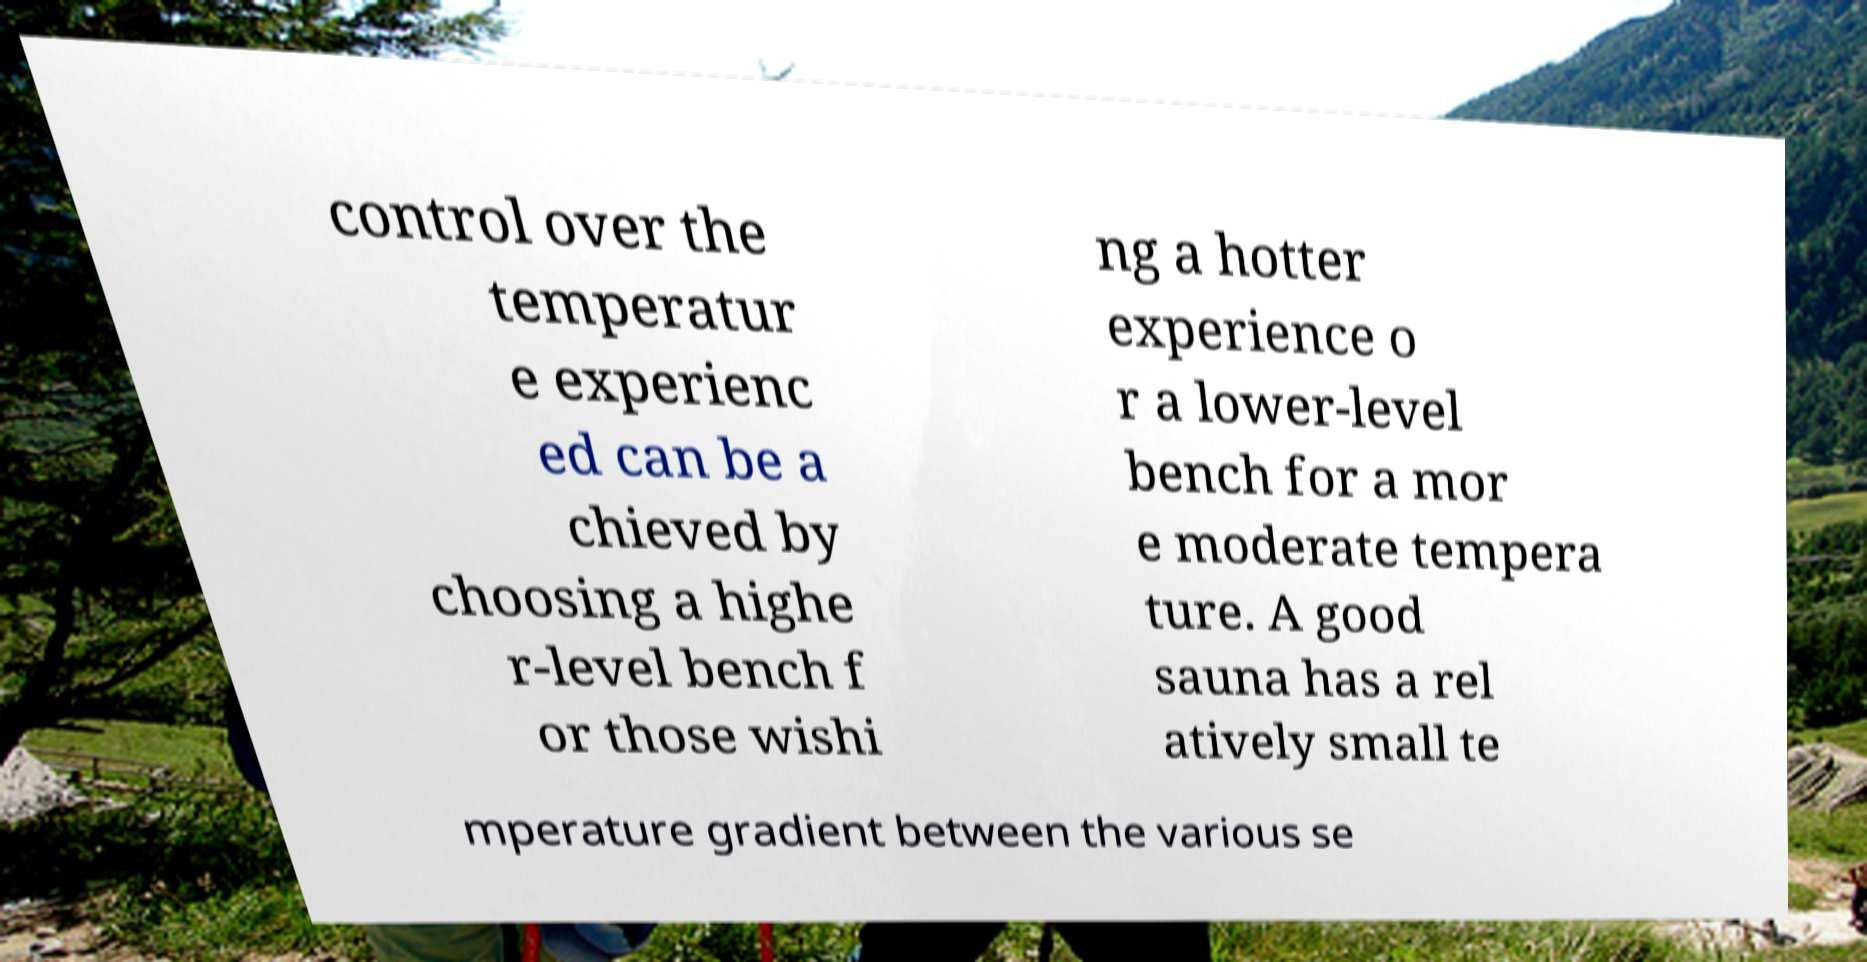Could you extract and type out the text from this image? control over the temperatur e experienc ed can be a chieved by choosing a highe r-level bench f or those wishi ng a hotter experience o r a lower-level bench for a mor e moderate tempera ture. A good sauna has a rel atively small te mperature gradient between the various se 